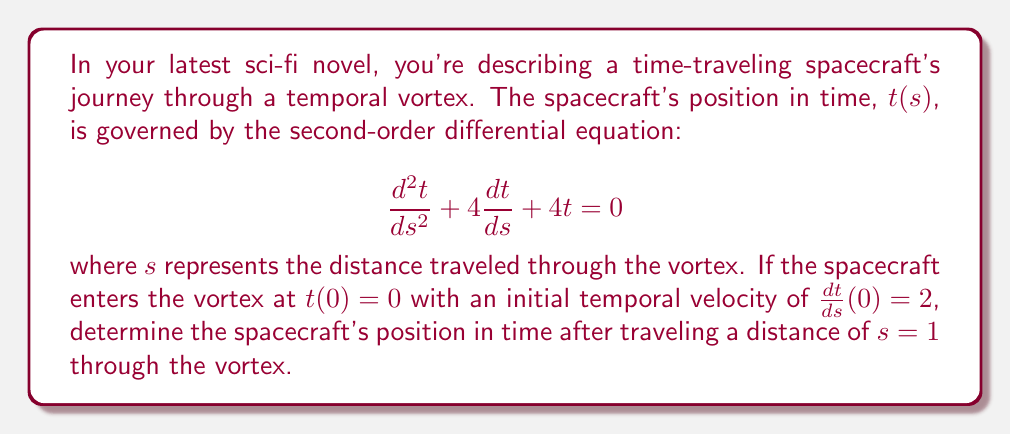Could you help me with this problem? To solve this problem, we need to follow these steps:

1) First, we recognize this as a second-order linear differential equation with constant coefficients. The characteristic equation is:

   $$r^2 + 4r + 4 = 0$$

2) Solving this equation:
   $$(r + 2)^2 = 0$$
   $$r = -2$$ (repeated root)

3) The general solution for a repeated root is:

   $$t(s) = (c_1 + c_2s)e^{-2s}$$

4) Now we use the initial conditions to find $c_1$ and $c_2$:

   At $s = 0$, $t(0) = 0$:
   $$0 = c_1$$

   For $\frac{dt}{ds}(0) = 2$:
   $$\frac{dt}{ds} = (-2c_1 - 2c_2s + c_2)e^{-2s}$$
   $$2 = -2(0) - 2(0) + c_2$$
   $$c_2 = 2$$

5) Therefore, the particular solution is:

   $$t(s) = 2se^{-2s}$$

6) To find $t(1)$, we simply plug in $s = 1$:

   $$t(1) = 2(1)e^{-2(1)} = 2e^{-2}$$
Answer: The spacecraft's position in time after traveling a distance of $s = 1$ through the vortex is $t(1) = 2e^{-2}$ time units. 